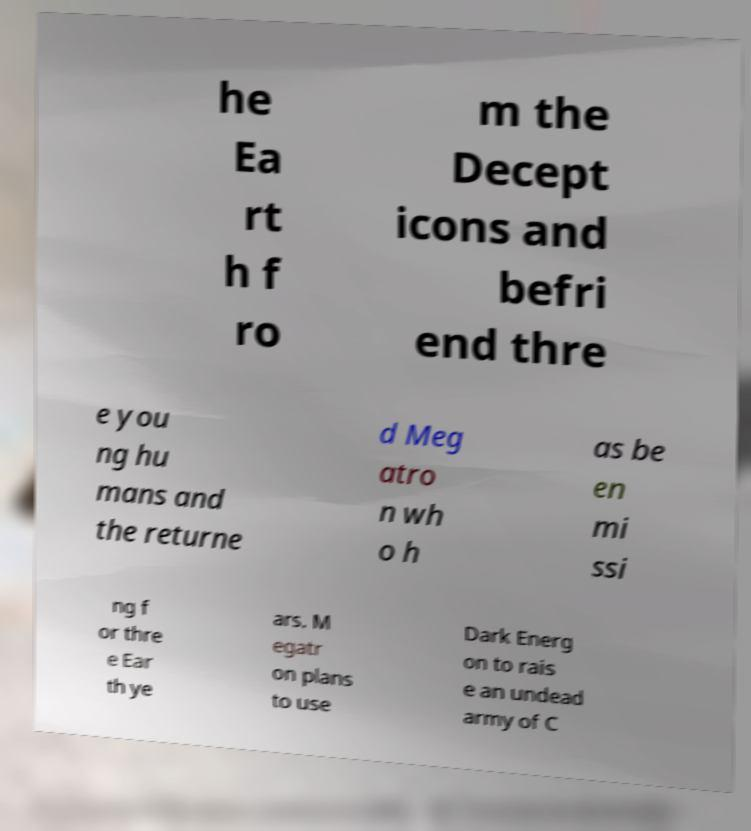Could you extract and type out the text from this image? he Ea rt h f ro m the Decept icons and befri end thre e you ng hu mans and the returne d Meg atro n wh o h as be en mi ssi ng f or thre e Ear th ye ars. M egatr on plans to use Dark Energ on to rais e an undead army of C 